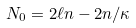Convert formula to latex. <formula><loc_0><loc_0><loc_500><loc_500>N _ { 0 } = 2 \ell n - 2 n / \kappa</formula> 